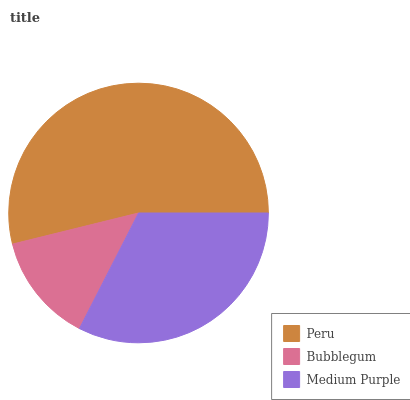Is Bubblegum the minimum?
Answer yes or no. Yes. Is Peru the maximum?
Answer yes or no. Yes. Is Medium Purple the minimum?
Answer yes or no. No. Is Medium Purple the maximum?
Answer yes or no. No. Is Medium Purple greater than Bubblegum?
Answer yes or no. Yes. Is Bubblegum less than Medium Purple?
Answer yes or no. Yes. Is Bubblegum greater than Medium Purple?
Answer yes or no. No. Is Medium Purple less than Bubblegum?
Answer yes or no. No. Is Medium Purple the high median?
Answer yes or no. Yes. Is Medium Purple the low median?
Answer yes or no. Yes. Is Peru the high median?
Answer yes or no. No. Is Peru the low median?
Answer yes or no. No. 